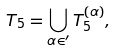<formula> <loc_0><loc_0><loc_500><loc_500>T _ { 5 } = \bigcup _ { \alpha \in \AA ^ { \prime } } T _ { 5 } ^ { ( \alpha ) } ,</formula> 